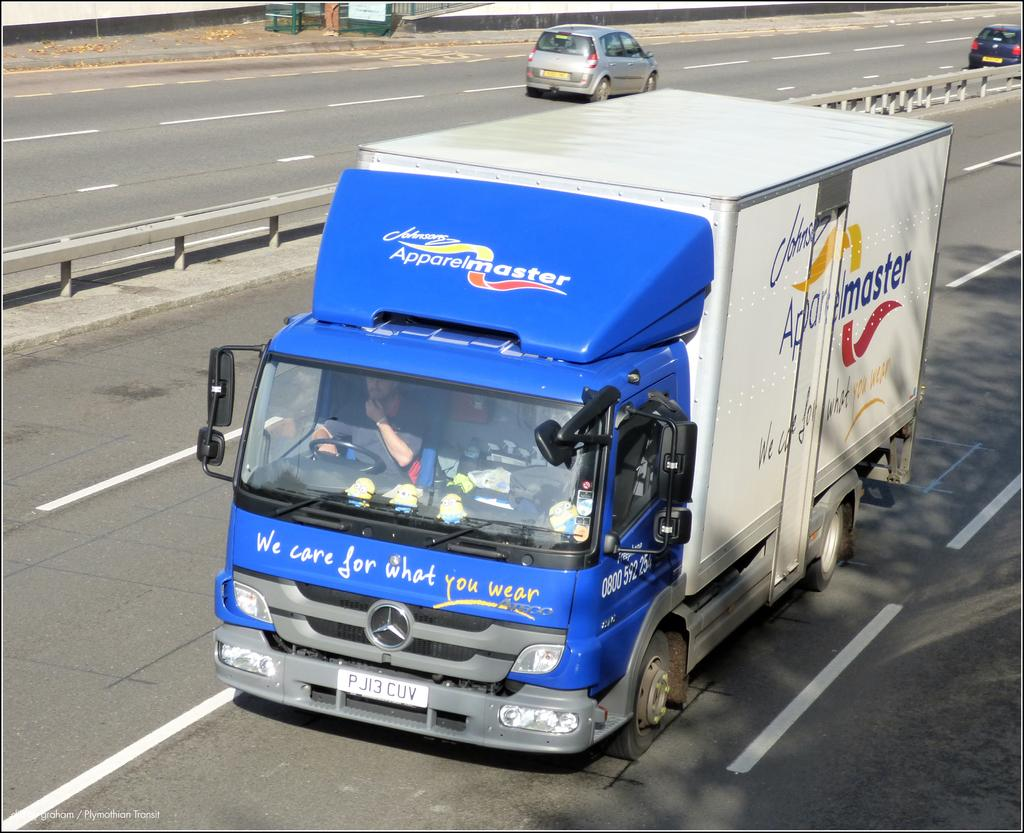What is happening on the road in the image? There are vehicles moving on the road in the image. What can be seen in the middle of the image? There is a railing at the center of the image. What is located at the top of the image? There is a metal structure at the top of the image. How many tomatoes can be seen hanging from the metal structure in the image? There are no tomatoes present in the image, and therefore none can be seen hanging from the metal structure. 